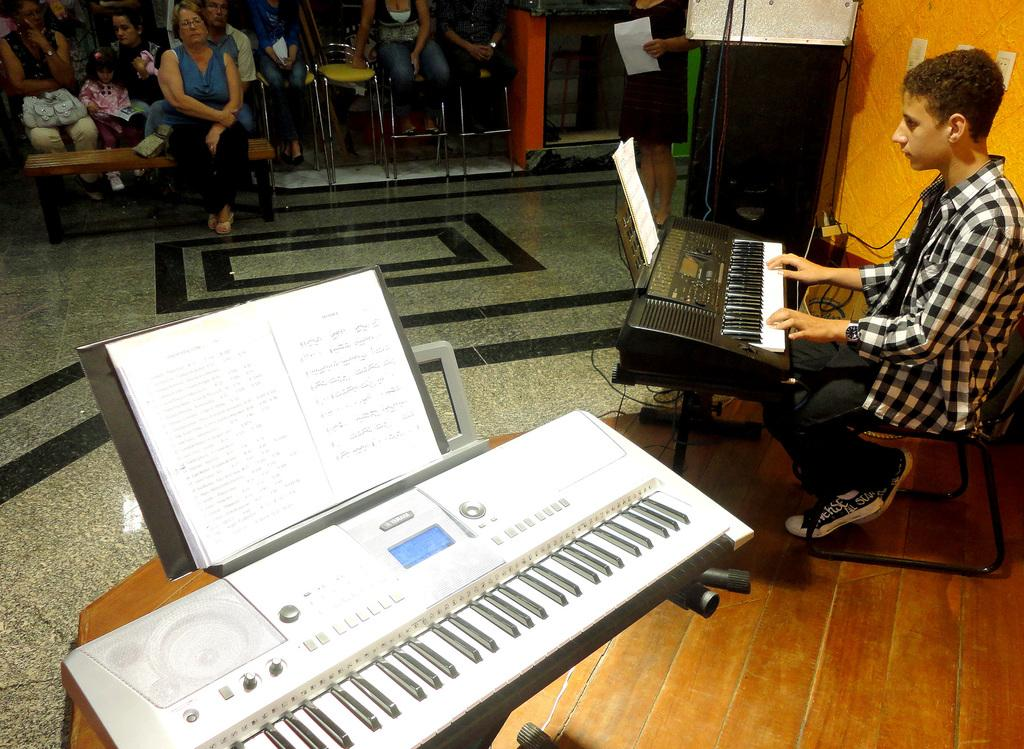What is the man in the image doing? The man is playing piano in the image. What can be seen beneath the man's feet? The image shows a floor. What are the people sitting on in the image? There are people sitting on chairs in the image. Can you identify any objects related to reading or learning in the image? Yes, there is a book visible in the image. What type of background is present in the image? There is a wall in the image. What type of silk material is draped over the piano in the image? There is no silk material draped over the piano in the image; it is not mentioned in the provided facts. 